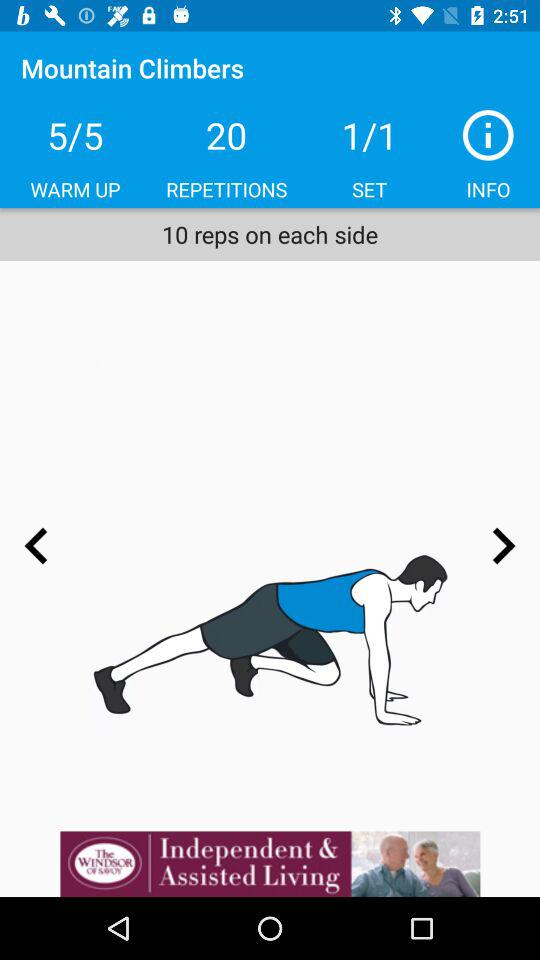How many reps on each side are there? There are 10 reps on each side. 